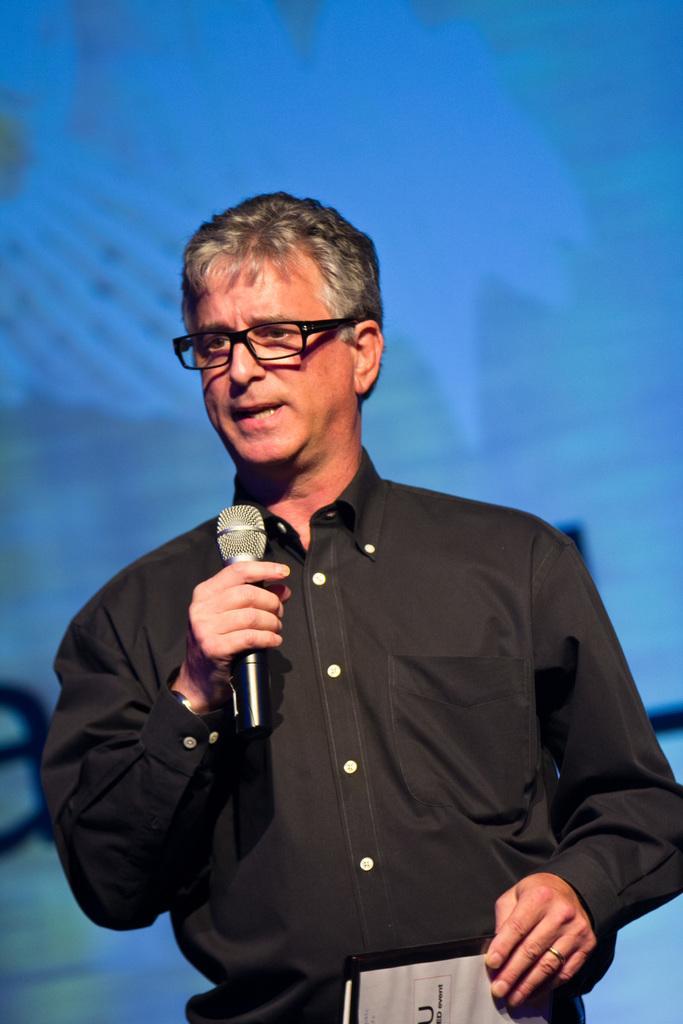Please provide a concise description of this image. In this image there is a man standing, holding a mike and other object in the hands and speaking. In the background there is a screen. 